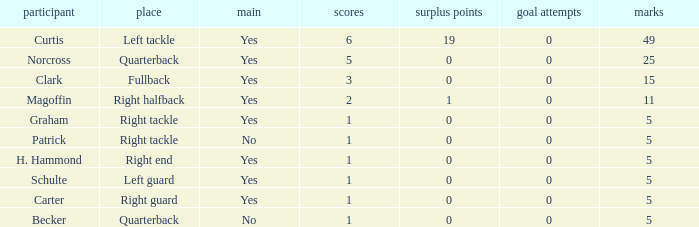Name the most touchdowns for becker  1.0. 